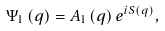<formula> <loc_0><loc_0><loc_500><loc_500>\Psi _ { 1 } \left ( q \right ) = A _ { 1 } \left ( q \right ) e ^ { i S \left ( q \right ) } ,</formula> 